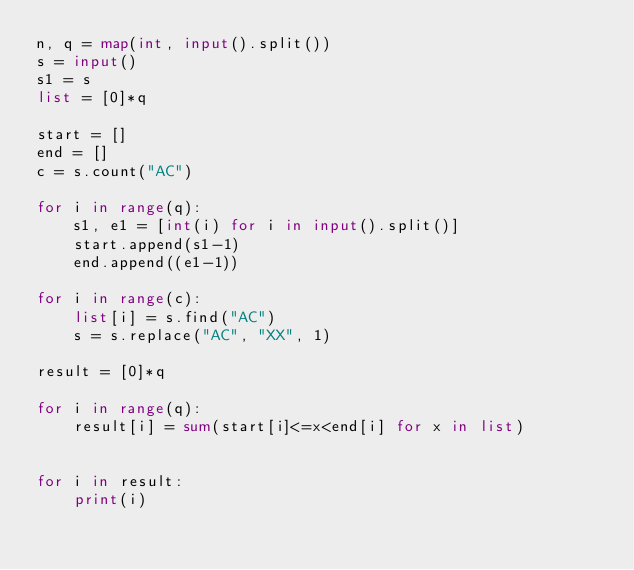Convert code to text. <code><loc_0><loc_0><loc_500><loc_500><_Python_>n, q = map(int, input().split())
s = input()
s1 = s
list = [0]*q

start = []
end = []
c = s.count("AC")

for i in range(q):
    s1, e1 = [int(i) for i in input().split()]
    start.append(s1-1)
    end.append((e1-1))

for i in range(c):
    list[i] = s.find("AC")
    s = s.replace("AC", "XX", 1)

result = [0]*q

for i in range(q):
    result[i] = sum(start[i]<=x<end[i] for x in list)


for i in result:
    print(i)

</code> 